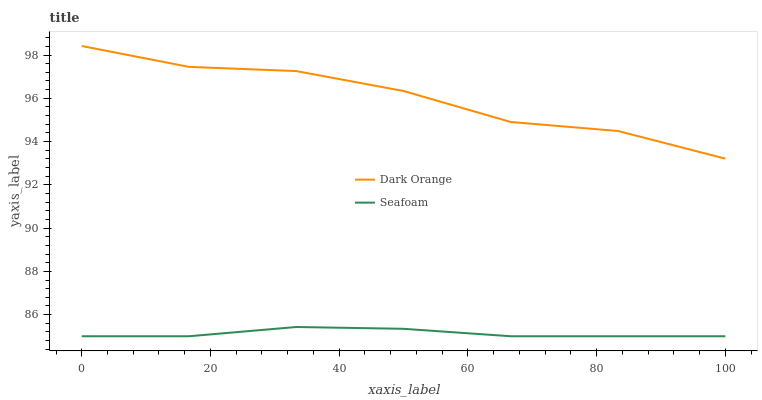Does Seafoam have the minimum area under the curve?
Answer yes or no. Yes. Does Dark Orange have the maximum area under the curve?
Answer yes or no. Yes. Does Seafoam have the maximum area under the curve?
Answer yes or no. No. Is Seafoam the smoothest?
Answer yes or no. Yes. Is Dark Orange the roughest?
Answer yes or no. Yes. Is Seafoam the roughest?
Answer yes or no. No. Does Seafoam have the lowest value?
Answer yes or no. Yes. Does Dark Orange have the highest value?
Answer yes or no. Yes. Does Seafoam have the highest value?
Answer yes or no. No. Is Seafoam less than Dark Orange?
Answer yes or no. Yes. Is Dark Orange greater than Seafoam?
Answer yes or no. Yes. Does Seafoam intersect Dark Orange?
Answer yes or no. No. 